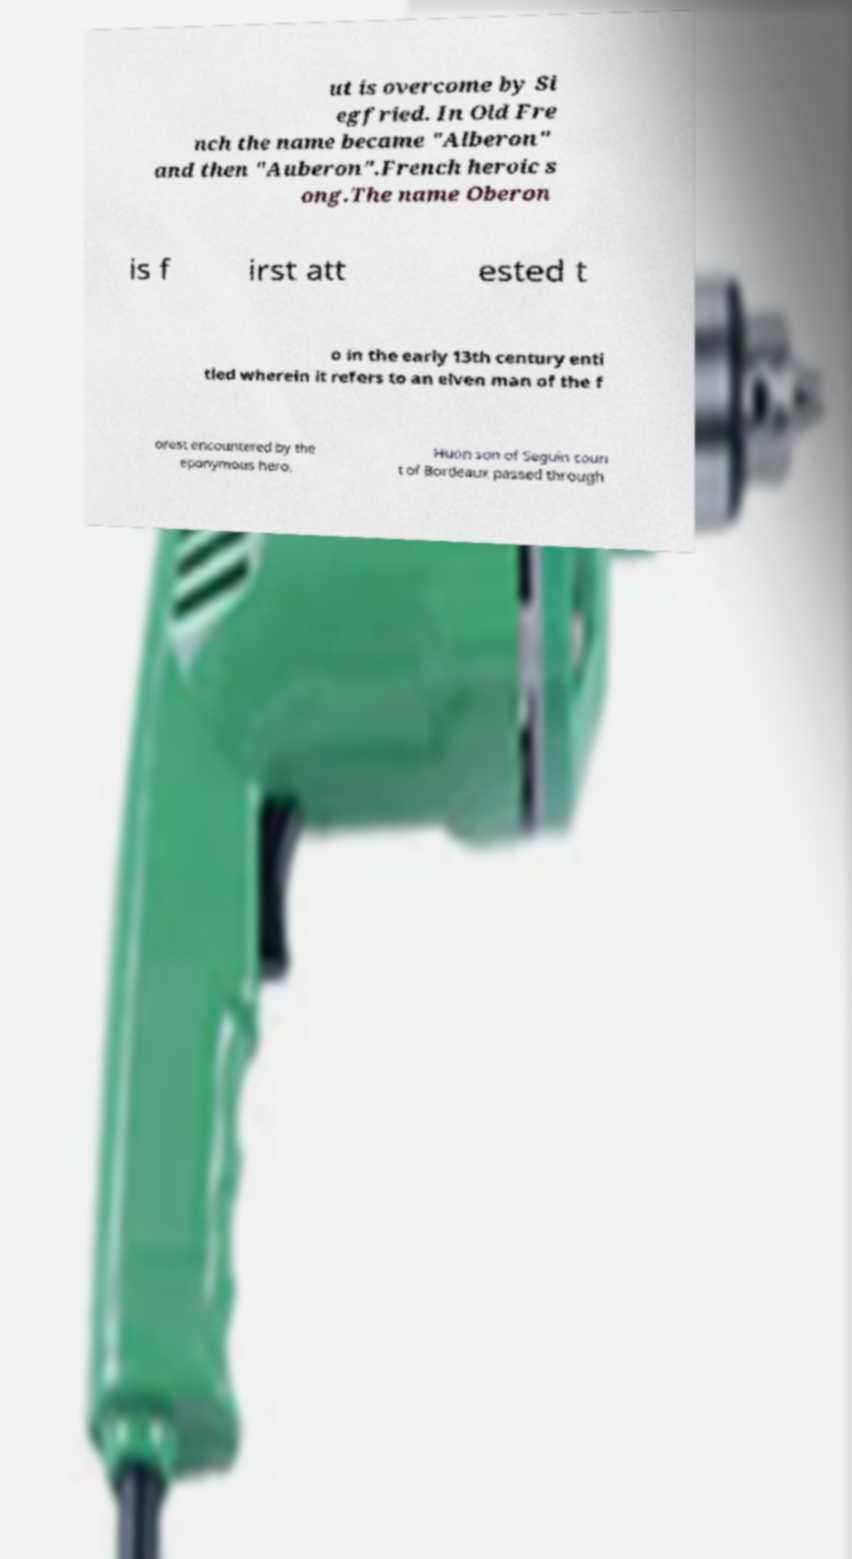Could you assist in decoding the text presented in this image and type it out clearly? ut is overcome by Si egfried. In Old Fre nch the name became "Alberon" and then "Auberon".French heroic s ong.The name Oberon is f irst att ested t o in the early 13th century enti tled wherein it refers to an elven man of the f orest encountered by the eponymous hero. Huon son of Seguin coun t of Bordeaux passed through 